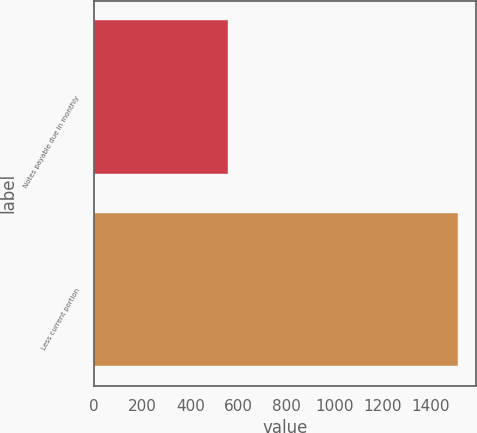<chart> <loc_0><loc_0><loc_500><loc_500><bar_chart><fcel>Notes payable due in monthly<fcel>Less current portion<nl><fcel>557<fcel>1511<nl></chart> 